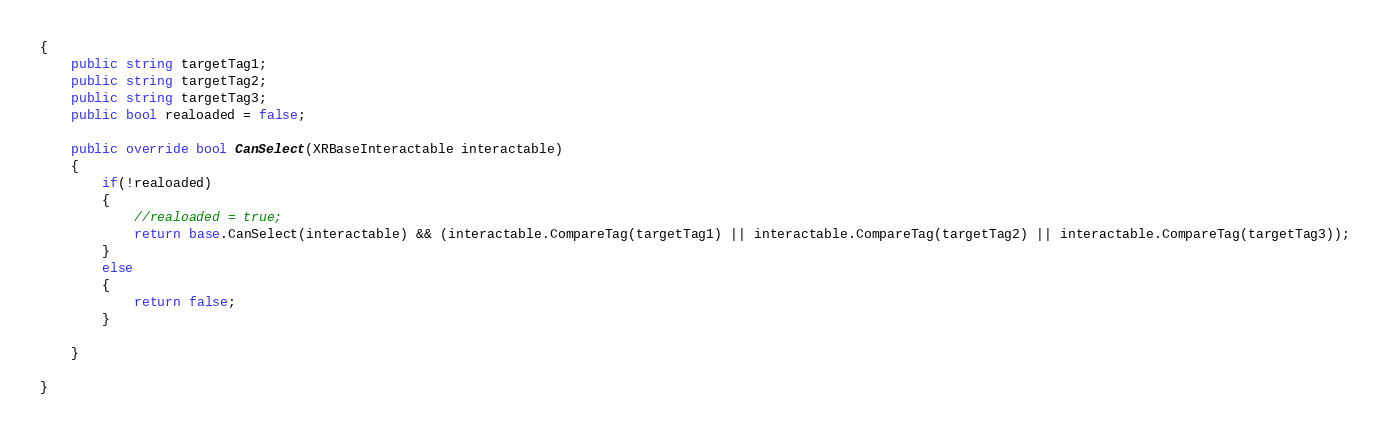<code> <loc_0><loc_0><loc_500><loc_500><_C#_>{
    public string targetTag1;
    public string targetTag2;
    public string targetTag3;
    public bool realoaded = false;

    public override bool CanSelect(XRBaseInteractable interactable)
    {
        if(!realoaded) 
        {
            //realoaded = true;
            return base.CanSelect(interactable) && (interactable.CompareTag(targetTag1) || interactable.CompareTag(targetTag2) || interactable.CompareTag(targetTag3));
        }
        else
        {
            return false;
        } 
            
    }
    
}
</code> 